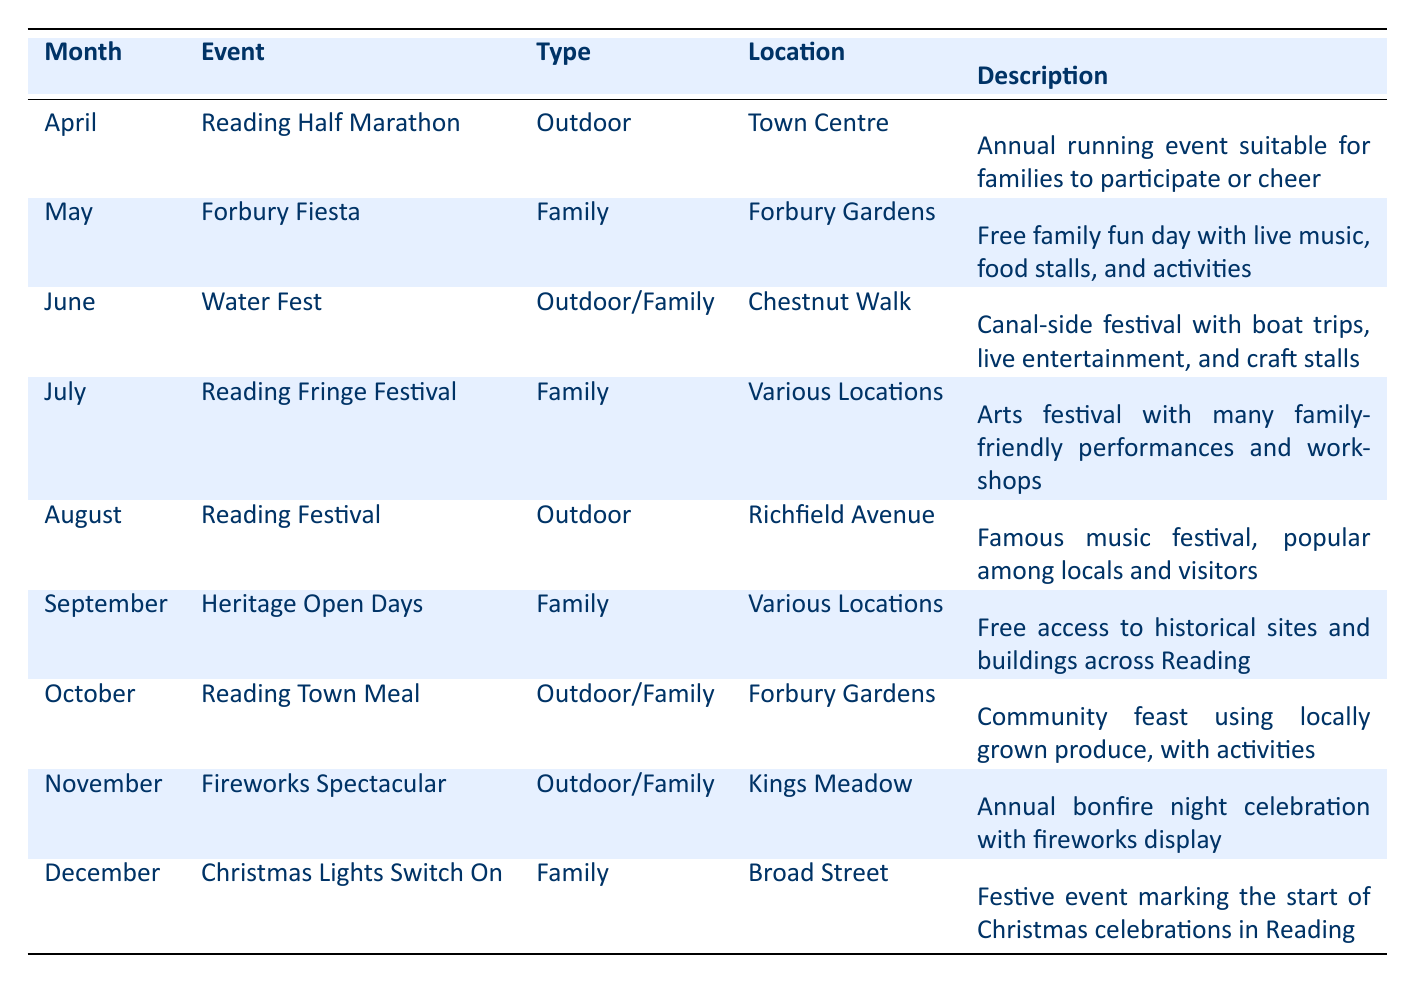What's the event taking place in June? The table shows that the event in June is "Water Fest."
Answer: Water Fest How many family-oriented events are listed in the table? The events categorized as family-oriented include: Forbury Fiesta, Reading Fringe Festival, Heritage Open Days, Christmas Lights Switch On, and the Reading Town Meal. This totals to five events.
Answer: 5 Which month has an outdoor festival that includes boat trips? In June, "Water Fest" is the outdoor festival mentioned that includes boat trips.
Answer: June Is the Reading Festival suitable for families? The Reading Festival is categorized as an outdoor event but is not explicitly listed as family-oriented. Therefore, the answer is no, it is not specifically marked as suitable for families.
Answer: No What is the location for the Forbury Fiesta? The table states that the Forbury Fiesta takes place at Forbury Gardens.
Answer: Forbury Gardens Can you name two events that are characterized as outdoor? The table lists the "Reading Half Marathon" in April and the "Reading Festival" in August as outdoor events.
Answer: Reading Half Marathon, Reading Festival Which event occurs in October, and what type is it? The event in October is the "Reading Town Meal" and it is categorized as outdoor/family.
Answer: Reading Town Meal, Outdoor/Family How many events take place in locations referred to as "Various Locations"? The events in "Various Locations" include the Reading Fringe Festival in July and the Heritage Open Days in September, totaling to two events.
Answer: 2 What is the month with the event that marks the start of Christmas celebrations? The month with the event marking the start of Christmas celebrations is December, specifically the "Christmas Lights Switch On."
Answer: December 